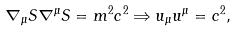Convert formula to latex. <formula><loc_0><loc_0><loc_500><loc_500>\nabla _ { \mu } S \nabla ^ { \mu } S = m ^ { 2 } c ^ { 2 } \Rightarrow u _ { \mu } u ^ { \mu } = c ^ { 2 } ,</formula> 